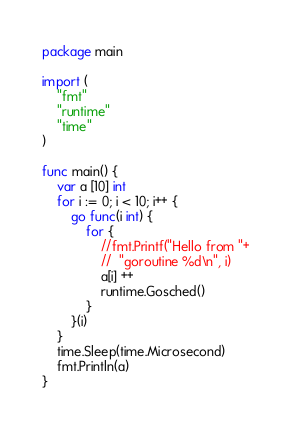Convert code to text. <code><loc_0><loc_0><loc_500><loc_500><_Go_>package main

import (
	"fmt"
	"runtime"
	"time"
)

func main() {
	var a [10] int
	for i := 0; i < 10; i++ {
		go func(i int) {
			for {
				//fmt.Printf("Hello from "+
				//	"goroutine %d\n", i)
				a[i] ++
				runtime.Gosched()
			}
		}(i)
	}
	time.Sleep(time.Microsecond)
	fmt.Println(a)
}
</code> 